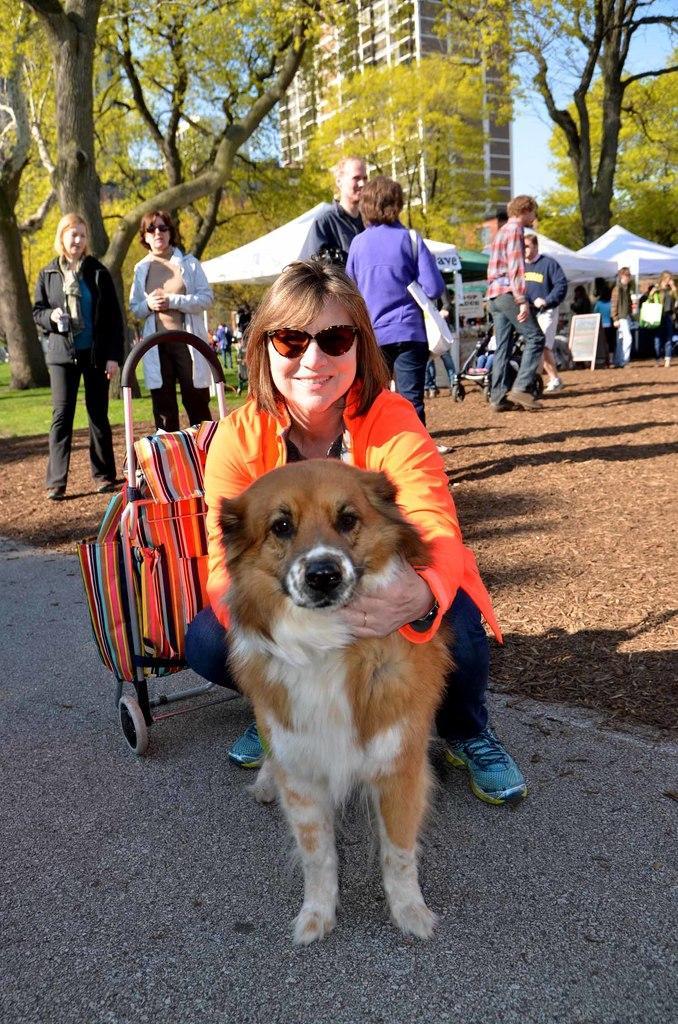How would you summarize this image in a sentence or two? In this image there are group of persons who are standing at the foreground of the image there is a lady person wearing orange color dress pampering a dog at the background there are trees and buildings. 